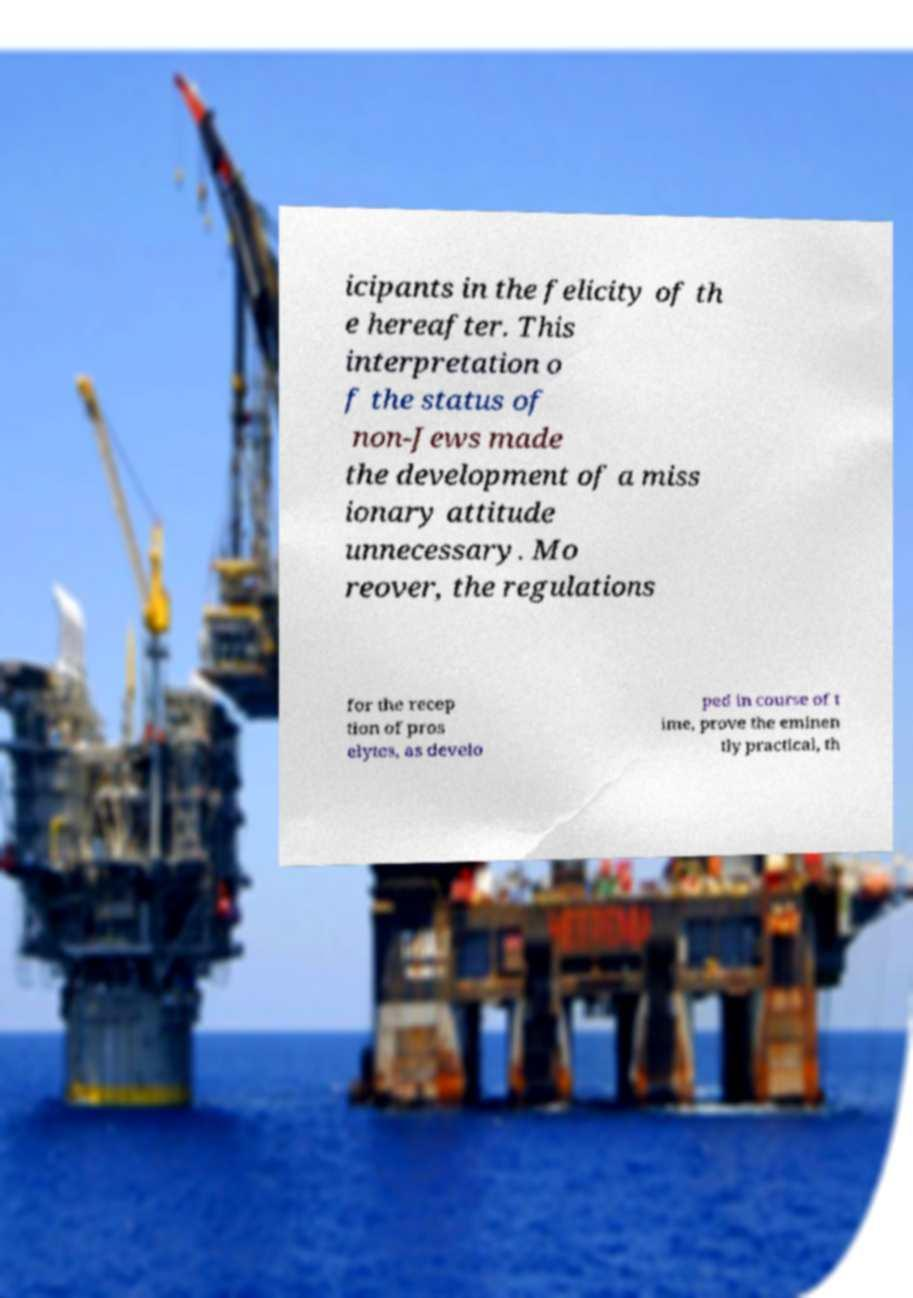Can you read and provide the text displayed in the image?This photo seems to have some interesting text. Can you extract and type it out for me? icipants in the felicity of th e hereafter. This interpretation o f the status of non-Jews made the development of a miss ionary attitude unnecessary. Mo reover, the regulations for the recep tion of pros elytes, as develo ped in course of t ime, prove the eminen tly practical, th 